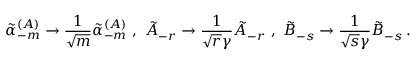<formula> <loc_0><loc_0><loc_500><loc_500>\tilde { \alpha } _ { - m } ^ { ( A ) } \rightarrow \frac { 1 } { \sqrt { m } } \tilde { \alpha } _ { - m } ^ { ( A ) } \, , \, \tilde { A } _ { - r } \rightarrow \frac { 1 } { \sqrt { r } \gamma } \tilde { A } _ { - r } \, , \, \tilde { B } _ { - s } \rightarrow \frac { 1 } { \sqrt { s } \gamma } \tilde { B } _ { - s } \, .</formula> 